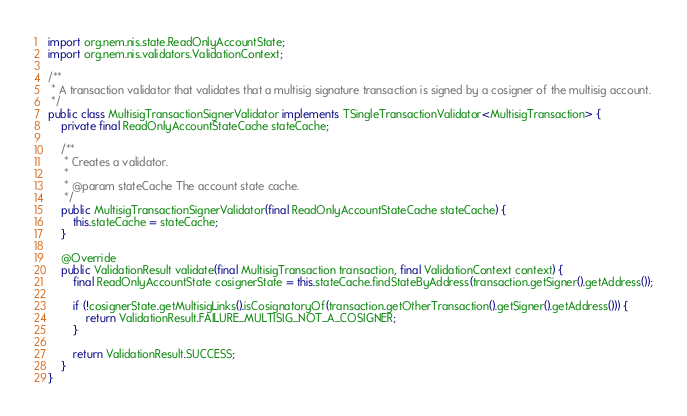Convert code to text. <code><loc_0><loc_0><loc_500><loc_500><_Java_>import org.nem.nis.state.ReadOnlyAccountState;
import org.nem.nis.validators.ValidationContext;

/**
 * A transaction validator that validates that a multisig signature transaction is signed by a cosigner of the multisig account.
 */
public class MultisigTransactionSignerValidator implements TSingleTransactionValidator<MultisigTransaction> {
	private final ReadOnlyAccountStateCache stateCache;

	/**
	 * Creates a validator.
	 *
	 * @param stateCache The account state cache.
	 */
	public MultisigTransactionSignerValidator(final ReadOnlyAccountStateCache stateCache) {
		this.stateCache = stateCache;
	}

	@Override
	public ValidationResult validate(final MultisigTransaction transaction, final ValidationContext context) {
		final ReadOnlyAccountState cosignerState = this.stateCache.findStateByAddress(transaction.getSigner().getAddress());

		if (!cosignerState.getMultisigLinks().isCosignatoryOf(transaction.getOtherTransaction().getSigner().getAddress())) {
			return ValidationResult.FAILURE_MULTISIG_NOT_A_COSIGNER;
		}

		return ValidationResult.SUCCESS;
	}
}
</code> 